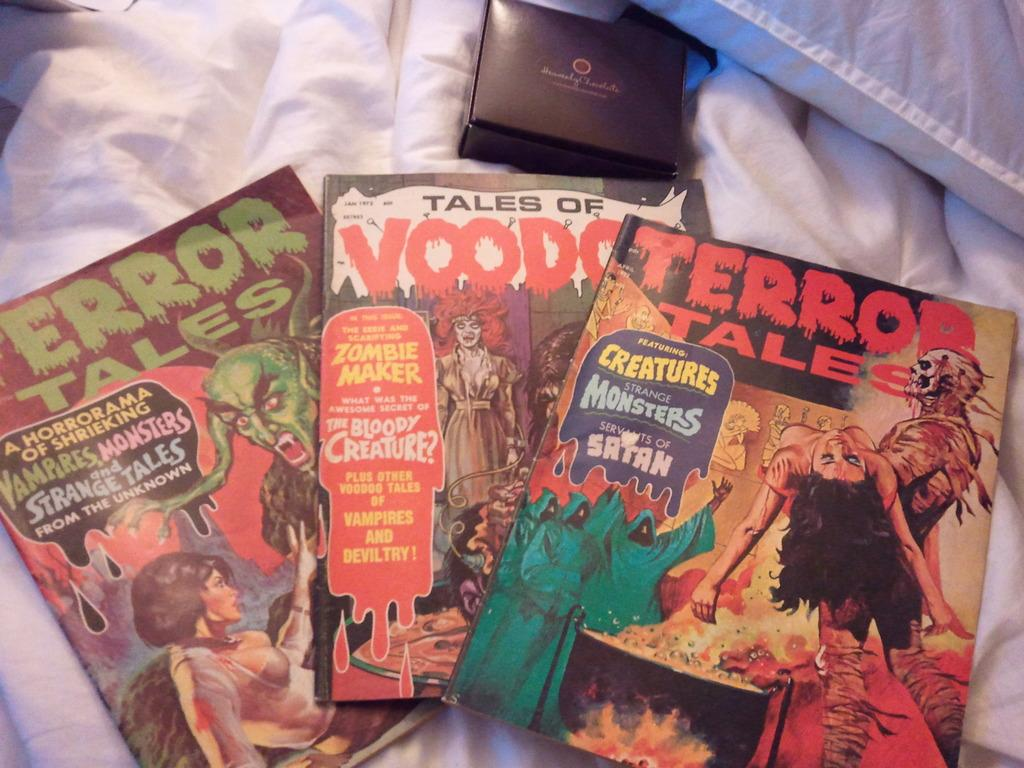<image>
Provide a brief description of the given image. Three comic books fanned out including two copies of Terror Tales and one copy of Tales of Voodoo. 